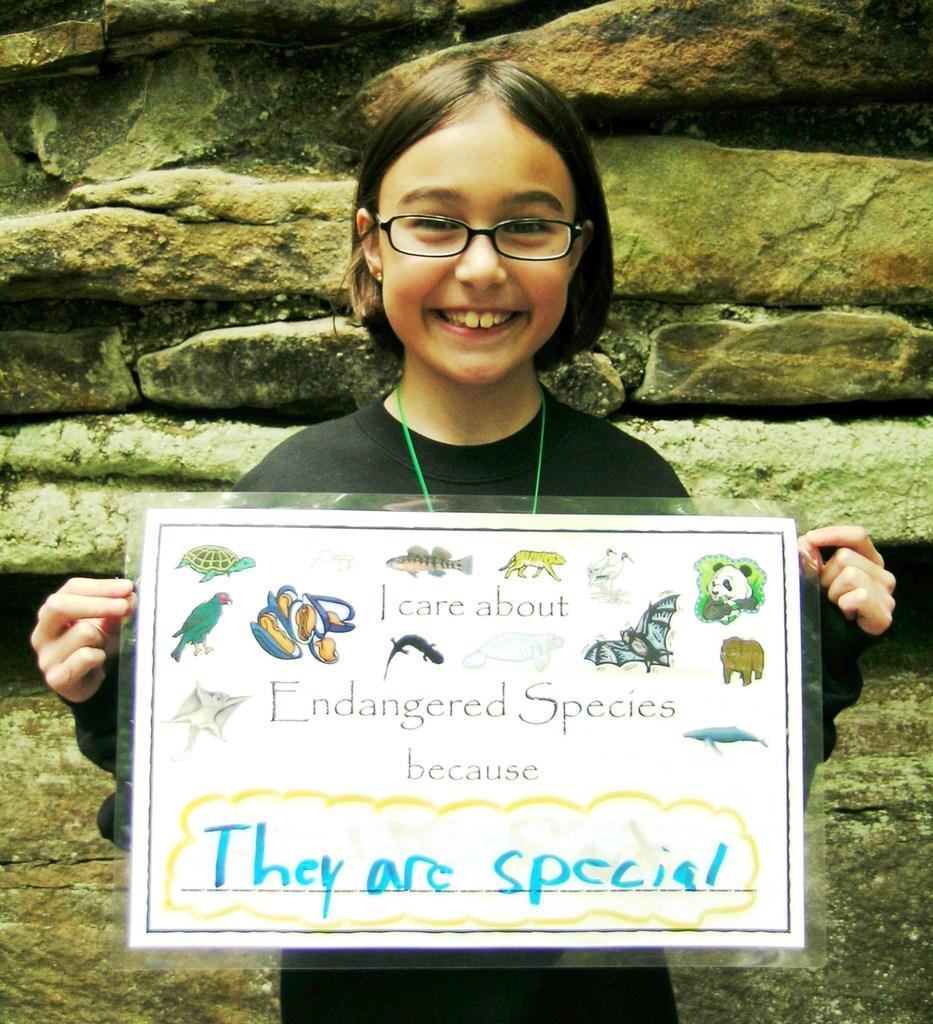In one or two sentences, can you explain what this image depicts? In this picture we can see a girl wore spectacles and smiling and holding a laminated paper with her hands and in the background we can see rocks. 